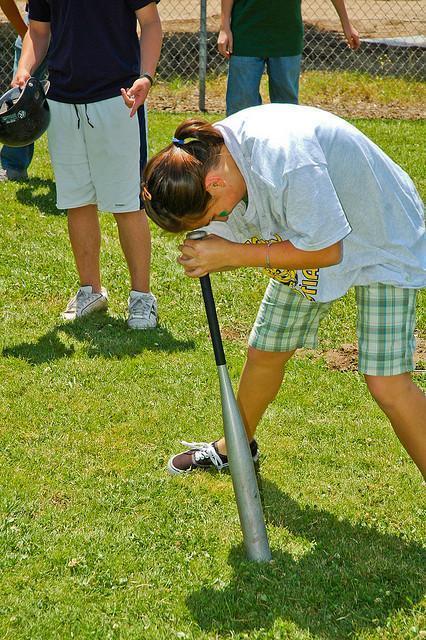How many people can be seen?
Give a very brief answer. 3. How many zebra are in this field?
Give a very brief answer. 0. 